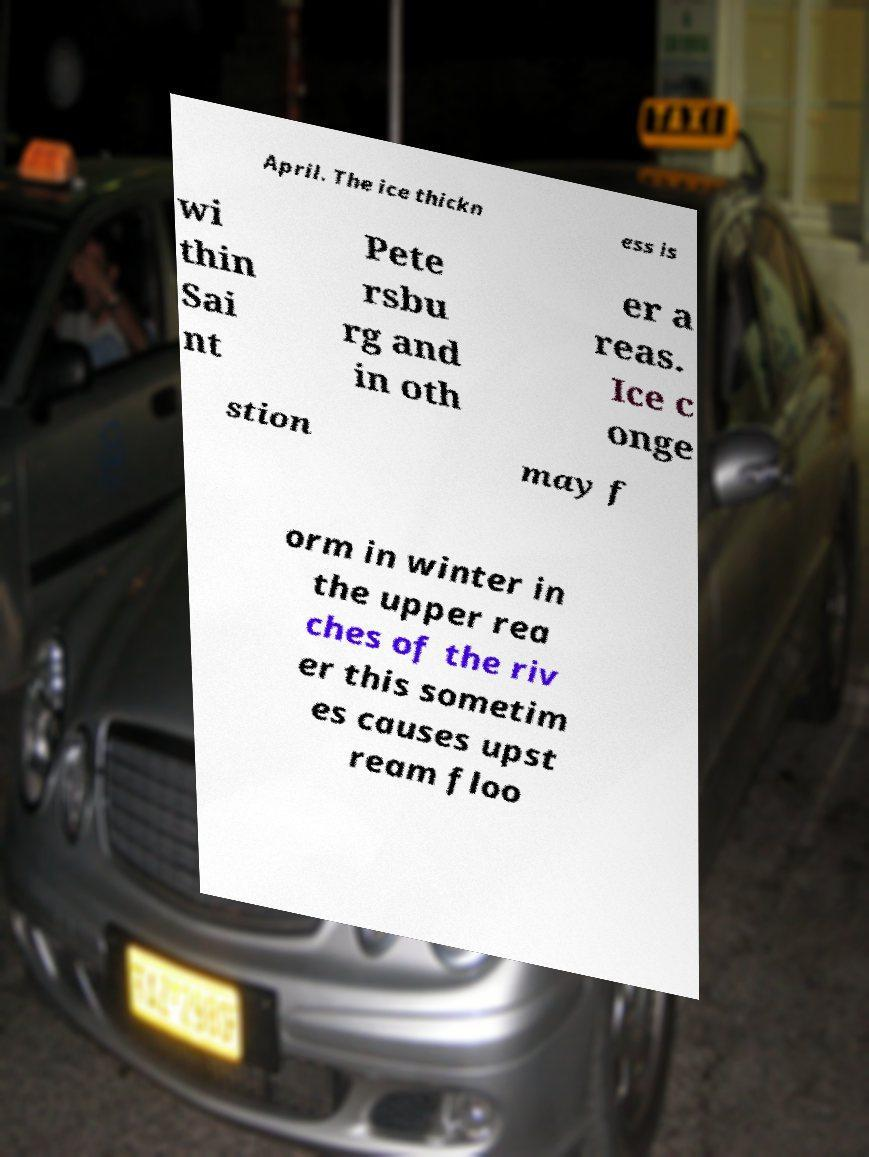What messages or text are displayed in this image? I need them in a readable, typed format. April. The ice thickn ess is wi thin Sai nt Pete rsbu rg and in oth er a reas. Ice c onge stion may f orm in winter in the upper rea ches of the riv er this sometim es causes upst ream floo 